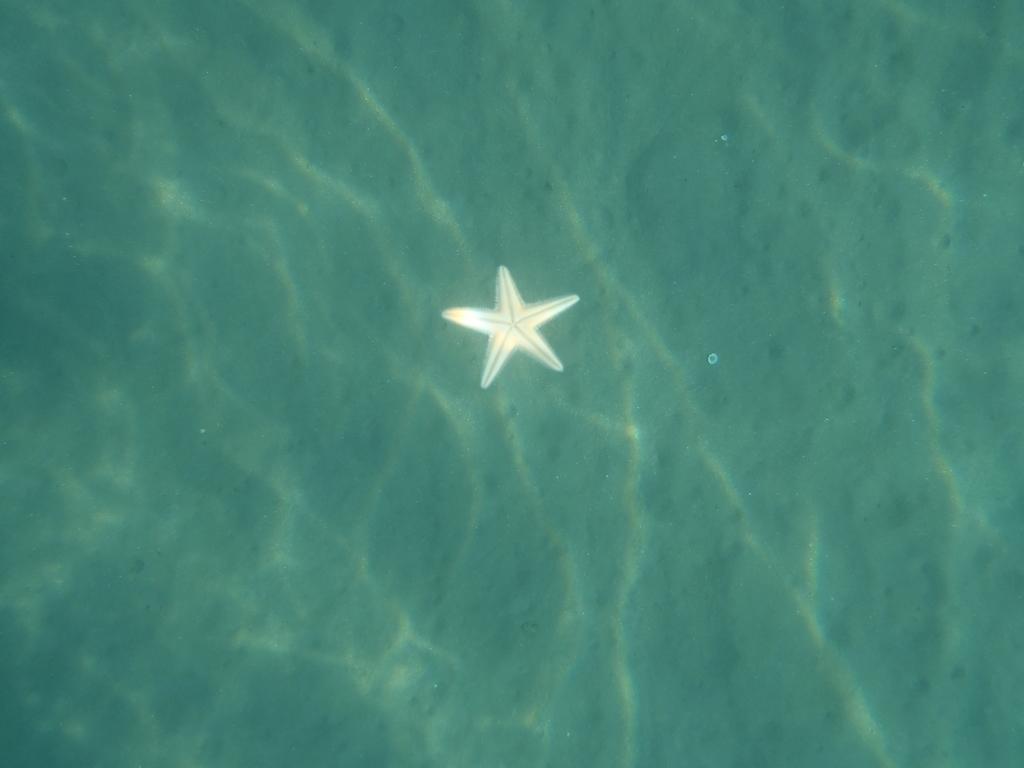In one or two sentences, can you explain what this image depicts? In this picture we can see a star fish and water. 